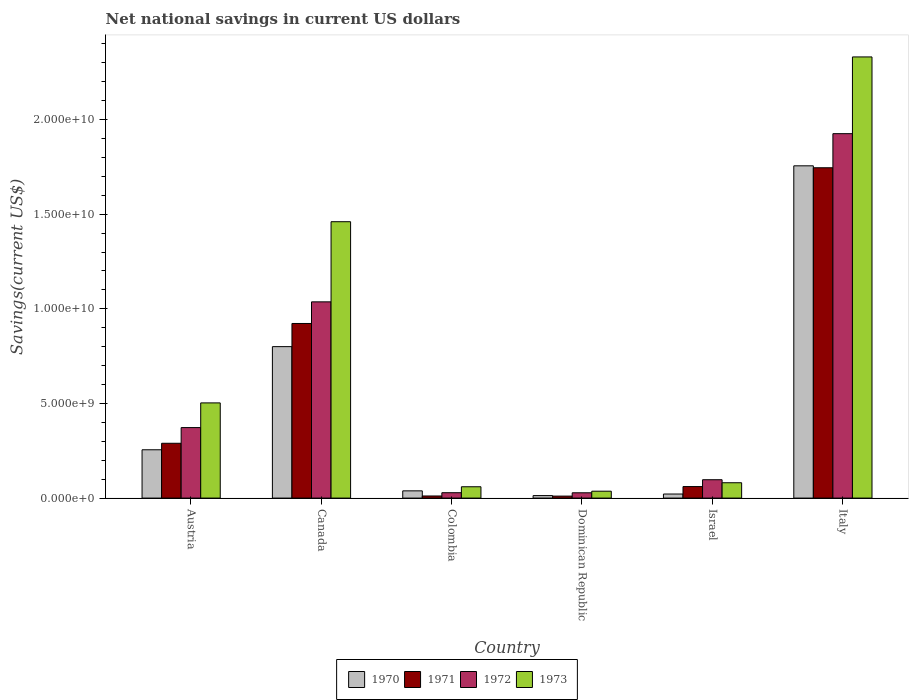How many different coloured bars are there?
Keep it short and to the point. 4. Are the number of bars per tick equal to the number of legend labels?
Provide a succinct answer. Yes. Are the number of bars on each tick of the X-axis equal?
Ensure brevity in your answer.  Yes. How many bars are there on the 1st tick from the left?
Make the answer very short. 4. What is the label of the 5th group of bars from the left?
Give a very brief answer. Israel. In how many cases, is the number of bars for a given country not equal to the number of legend labels?
Offer a terse response. 0. What is the net national savings in 1972 in Colombia?
Provide a succinct answer. 2.84e+08. Across all countries, what is the maximum net national savings in 1971?
Provide a succinct answer. 1.75e+1. Across all countries, what is the minimum net national savings in 1970?
Your response must be concise. 1.33e+08. In which country was the net national savings in 1970 minimum?
Ensure brevity in your answer.  Dominican Republic. What is the total net national savings in 1971 in the graph?
Your response must be concise. 3.04e+1. What is the difference between the net national savings in 1971 in Canada and that in Italy?
Ensure brevity in your answer.  -8.23e+09. What is the difference between the net national savings in 1971 in Austria and the net national savings in 1972 in Dominican Republic?
Provide a short and direct response. 2.62e+09. What is the average net national savings in 1973 per country?
Keep it short and to the point. 7.45e+09. What is the difference between the net national savings of/in 1970 and net national savings of/in 1971 in Dominican Republic?
Your answer should be very brief. 2.74e+07. What is the ratio of the net national savings in 1970 in Colombia to that in Italy?
Provide a succinct answer. 0.02. What is the difference between the highest and the second highest net national savings in 1972?
Give a very brief answer. 8.89e+09. What is the difference between the highest and the lowest net national savings in 1971?
Your answer should be compact. 1.73e+1. Is the sum of the net national savings in 1971 in Dominican Republic and Israel greater than the maximum net national savings in 1970 across all countries?
Your answer should be compact. No. Is it the case that in every country, the sum of the net national savings in 1971 and net national savings in 1970 is greater than the net national savings in 1973?
Provide a short and direct response. No. How many bars are there?
Your answer should be very brief. 24. Are all the bars in the graph horizontal?
Offer a terse response. No. What is the difference between two consecutive major ticks on the Y-axis?
Ensure brevity in your answer.  5.00e+09. Are the values on the major ticks of Y-axis written in scientific E-notation?
Ensure brevity in your answer.  Yes. Does the graph contain grids?
Your answer should be very brief. No. Where does the legend appear in the graph?
Offer a terse response. Bottom center. How many legend labels are there?
Keep it short and to the point. 4. What is the title of the graph?
Your response must be concise. Net national savings in current US dollars. What is the label or title of the X-axis?
Your answer should be very brief. Country. What is the label or title of the Y-axis?
Your answer should be very brief. Savings(current US$). What is the Savings(current US$) of 1970 in Austria?
Give a very brief answer. 2.55e+09. What is the Savings(current US$) in 1971 in Austria?
Your answer should be very brief. 2.90e+09. What is the Savings(current US$) of 1972 in Austria?
Make the answer very short. 3.73e+09. What is the Savings(current US$) in 1973 in Austria?
Make the answer very short. 5.03e+09. What is the Savings(current US$) in 1970 in Canada?
Offer a very short reply. 8.00e+09. What is the Savings(current US$) in 1971 in Canada?
Your response must be concise. 9.23e+09. What is the Savings(current US$) of 1972 in Canada?
Provide a succinct answer. 1.04e+1. What is the Savings(current US$) in 1973 in Canada?
Keep it short and to the point. 1.46e+1. What is the Savings(current US$) in 1970 in Colombia?
Offer a very short reply. 3.83e+08. What is the Savings(current US$) in 1971 in Colombia?
Keep it short and to the point. 1.11e+08. What is the Savings(current US$) in 1972 in Colombia?
Make the answer very short. 2.84e+08. What is the Savings(current US$) of 1973 in Colombia?
Ensure brevity in your answer.  5.98e+08. What is the Savings(current US$) of 1970 in Dominican Republic?
Make the answer very short. 1.33e+08. What is the Savings(current US$) of 1971 in Dominican Republic?
Provide a short and direct response. 1.05e+08. What is the Savings(current US$) in 1972 in Dominican Republic?
Your answer should be very brief. 2.80e+08. What is the Savings(current US$) in 1973 in Dominican Republic?
Provide a short and direct response. 3.65e+08. What is the Savings(current US$) of 1970 in Israel?
Your answer should be compact. 2.15e+08. What is the Savings(current US$) in 1971 in Israel?
Offer a very short reply. 6.09e+08. What is the Savings(current US$) in 1972 in Israel?
Offer a terse response. 9.71e+08. What is the Savings(current US$) in 1973 in Israel?
Your answer should be compact. 8.11e+08. What is the Savings(current US$) of 1970 in Italy?
Provide a succinct answer. 1.76e+1. What is the Savings(current US$) in 1971 in Italy?
Provide a succinct answer. 1.75e+1. What is the Savings(current US$) of 1972 in Italy?
Provide a succinct answer. 1.93e+1. What is the Savings(current US$) in 1973 in Italy?
Offer a very short reply. 2.33e+1. Across all countries, what is the maximum Savings(current US$) in 1970?
Keep it short and to the point. 1.76e+1. Across all countries, what is the maximum Savings(current US$) in 1971?
Make the answer very short. 1.75e+1. Across all countries, what is the maximum Savings(current US$) of 1972?
Offer a very short reply. 1.93e+1. Across all countries, what is the maximum Savings(current US$) in 1973?
Your response must be concise. 2.33e+1. Across all countries, what is the minimum Savings(current US$) in 1970?
Provide a succinct answer. 1.33e+08. Across all countries, what is the minimum Savings(current US$) of 1971?
Make the answer very short. 1.05e+08. Across all countries, what is the minimum Savings(current US$) of 1972?
Your response must be concise. 2.80e+08. Across all countries, what is the minimum Savings(current US$) in 1973?
Provide a short and direct response. 3.65e+08. What is the total Savings(current US$) of 1970 in the graph?
Provide a short and direct response. 2.88e+1. What is the total Savings(current US$) of 1971 in the graph?
Keep it short and to the point. 3.04e+1. What is the total Savings(current US$) in 1972 in the graph?
Give a very brief answer. 3.49e+1. What is the total Savings(current US$) in 1973 in the graph?
Give a very brief answer. 4.47e+1. What is the difference between the Savings(current US$) in 1970 in Austria and that in Canada?
Ensure brevity in your answer.  -5.45e+09. What is the difference between the Savings(current US$) of 1971 in Austria and that in Canada?
Provide a succinct answer. -6.33e+09. What is the difference between the Savings(current US$) in 1972 in Austria and that in Canada?
Your answer should be very brief. -6.64e+09. What is the difference between the Savings(current US$) of 1973 in Austria and that in Canada?
Make the answer very short. -9.57e+09. What is the difference between the Savings(current US$) in 1970 in Austria and that in Colombia?
Provide a succinct answer. 2.17e+09. What is the difference between the Savings(current US$) of 1971 in Austria and that in Colombia?
Your answer should be very brief. 2.78e+09. What is the difference between the Savings(current US$) in 1972 in Austria and that in Colombia?
Give a very brief answer. 3.44e+09. What is the difference between the Savings(current US$) in 1973 in Austria and that in Colombia?
Ensure brevity in your answer.  4.43e+09. What is the difference between the Savings(current US$) of 1970 in Austria and that in Dominican Republic?
Ensure brevity in your answer.  2.42e+09. What is the difference between the Savings(current US$) in 1971 in Austria and that in Dominican Republic?
Your answer should be very brief. 2.79e+09. What is the difference between the Savings(current US$) in 1972 in Austria and that in Dominican Republic?
Give a very brief answer. 3.44e+09. What is the difference between the Savings(current US$) in 1973 in Austria and that in Dominican Republic?
Your response must be concise. 4.66e+09. What is the difference between the Savings(current US$) of 1970 in Austria and that in Israel?
Your answer should be compact. 2.34e+09. What is the difference between the Savings(current US$) of 1971 in Austria and that in Israel?
Provide a short and direct response. 2.29e+09. What is the difference between the Savings(current US$) in 1972 in Austria and that in Israel?
Your answer should be compact. 2.75e+09. What is the difference between the Savings(current US$) of 1973 in Austria and that in Israel?
Make the answer very short. 4.22e+09. What is the difference between the Savings(current US$) in 1970 in Austria and that in Italy?
Offer a very short reply. -1.50e+1. What is the difference between the Savings(current US$) of 1971 in Austria and that in Italy?
Your answer should be compact. -1.46e+1. What is the difference between the Savings(current US$) in 1972 in Austria and that in Italy?
Provide a succinct answer. -1.55e+1. What is the difference between the Savings(current US$) in 1973 in Austria and that in Italy?
Keep it short and to the point. -1.83e+1. What is the difference between the Savings(current US$) in 1970 in Canada and that in Colombia?
Offer a terse response. 7.62e+09. What is the difference between the Savings(current US$) of 1971 in Canada and that in Colombia?
Provide a short and direct response. 9.11e+09. What is the difference between the Savings(current US$) in 1972 in Canada and that in Colombia?
Keep it short and to the point. 1.01e+1. What is the difference between the Savings(current US$) of 1973 in Canada and that in Colombia?
Provide a short and direct response. 1.40e+1. What is the difference between the Savings(current US$) of 1970 in Canada and that in Dominican Republic?
Your response must be concise. 7.87e+09. What is the difference between the Savings(current US$) in 1971 in Canada and that in Dominican Republic?
Give a very brief answer. 9.12e+09. What is the difference between the Savings(current US$) in 1972 in Canada and that in Dominican Republic?
Provide a short and direct response. 1.01e+1. What is the difference between the Savings(current US$) of 1973 in Canada and that in Dominican Republic?
Your answer should be very brief. 1.42e+1. What is the difference between the Savings(current US$) of 1970 in Canada and that in Israel?
Provide a short and direct response. 7.79e+09. What is the difference between the Savings(current US$) in 1971 in Canada and that in Israel?
Offer a very short reply. 8.62e+09. What is the difference between the Savings(current US$) in 1972 in Canada and that in Israel?
Give a very brief answer. 9.40e+09. What is the difference between the Savings(current US$) of 1973 in Canada and that in Israel?
Your response must be concise. 1.38e+1. What is the difference between the Savings(current US$) of 1970 in Canada and that in Italy?
Give a very brief answer. -9.55e+09. What is the difference between the Savings(current US$) of 1971 in Canada and that in Italy?
Give a very brief answer. -8.23e+09. What is the difference between the Savings(current US$) of 1972 in Canada and that in Italy?
Offer a very short reply. -8.89e+09. What is the difference between the Savings(current US$) of 1973 in Canada and that in Italy?
Provide a short and direct response. -8.71e+09. What is the difference between the Savings(current US$) of 1970 in Colombia and that in Dominican Republic?
Provide a short and direct response. 2.50e+08. What is the difference between the Savings(current US$) of 1971 in Colombia and that in Dominican Republic?
Offer a terse response. 6.03e+06. What is the difference between the Savings(current US$) of 1972 in Colombia and that in Dominican Republic?
Make the answer very short. 3.48e+06. What is the difference between the Savings(current US$) of 1973 in Colombia and that in Dominican Republic?
Offer a very short reply. 2.34e+08. What is the difference between the Savings(current US$) in 1970 in Colombia and that in Israel?
Keep it short and to the point. 1.68e+08. What is the difference between the Savings(current US$) in 1971 in Colombia and that in Israel?
Provide a short and direct response. -4.97e+08. What is the difference between the Savings(current US$) in 1972 in Colombia and that in Israel?
Offer a very short reply. -6.87e+08. What is the difference between the Savings(current US$) in 1973 in Colombia and that in Israel?
Your answer should be compact. -2.12e+08. What is the difference between the Savings(current US$) in 1970 in Colombia and that in Italy?
Give a very brief answer. -1.72e+1. What is the difference between the Savings(current US$) of 1971 in Colombia and that in Italy?
Provide a short and direct response. -1.73e+1. What is the difference between the Savings(current US$) of 1972 in Colombia and that in Italy?
Your answer should be very brief. -1.90e+1. What is the difference between the Savings(current US$) in 1973 in Colombia and that in Italy?
Your response must be concise. -2.27e+1. What is the difference between the Savings(current US$) in 1970 in Dominican Republic and that in Israel?
Provide a succinct answer. -8.19e+07. What is the difference between the Savings(current US$) in 1971 in Dominican Republic and that in Israel?
Keep it short and to the point. -5.03e+08. What is the difference between the Savings(current US$) in 1972 in Dominican Republic and that in Israel?
Offer a very short reply. -6.90e+08. What is the difference between the Savings(current US$) in 1973 in Dominican Republic and that in Israel?
Your answer should be very brief. -4.46e+08. What is the difference between the Savings(current US$) in 1970 in Dominican Republic and that in Italy?
Make the answer very short. -1.74e+1. What is the difference between the Savings(current US$) in 1971 in Dominican Republic and that in Italy?
Your answer should be very brief. -1.73e+1. What is the difference between the Savings(current US$) in 1972 in Dominican Republic and that in Italy?
Provide a succinct answer. -1.90e+1. What is the difference between the Savings(current US$) of 1973 in Dominican Republic and that in Italy?
Offer a very short reply. -2.29e+1. What is the difference between the Savings(current US$) of 1970 in Israel and that in Italy?
Your response must be concise. -1.73e+1. What is the difference between the Savings(current US$) in 1971 in Israel and that in Italy?
Ensure brevity in your answer.  -1.68e+1. What is the difference between the Savings(current US$) in 1972 in Israel and that in Italy?
Your answer should be compact. -1.83e+1. What is the difference between the Savings(current US$) in 1973 in Israel and that in Italy?
Provide a succinct answer. -2.25e+1. What is the difference between the Savings(current US$) in 1970 in Austria and the Savings(current US$) in 1971 in Canada?
Offer a terse response. -6.67e+09. What is the difference between the Savings(current US$) of 1970 in Austria and the Savings(current US$) of 1972 in Canada?
Your response must be concise. -7.82e+09. What is the difference between the Savings(current US$) in 1970 in Austria and the Savings(current US$) in 1973 in Canada?
Your answer should be very brief. -1.20e+1. What is the difference between the Savings(current US$) in 1971 in Austria and the Savings(current US$) in 1972 in Canada?
Keep it short and to the point. -7.47e+09. What is the difference between the Savings(current US$) in 1971 in Austria and the Savings(current US$) in 1973 in Canada?
Your answer should be compact. -1.17e+1. What is the difference between the Savings(current US$) in 1972 in Austria and the Savings(current US$) in 1973 in Canada?
Provide a succinct answer. -1.09e+1. What is the difference between the Savings(current US$) in 1970 in Austria and the Savings(current US$) in 1971 in Colombia?
Make the answer very short. 2.44e+09. What is the difference between the Savings(current US$) of 1970 in Austria and the Savings(current US$) of 1972 in Colombia?
Provide a succinct answer. 2.27e+09. What is the difference between the Savings(current US$) of 1970 in Austria and the Savings(current US$) of 1973 in Colombia?
Offer a terse response. 1.95e+09. What is the difference between the Savings(current US$) in 1971 in Austria and the Savings(current US$) in 1972 in Colombia?
Make the answer very short. 2.61e+09. What is the difference between the Savings(current US$) in 1971 in Austria and the Savings(current US$) in 1973 in Colombia?
Ensure brevity in your answer.  2.30e+09. What is the difference between the Savings(current US$) of 1972 in Austria and the Savings(current US$) of 1973 in Colombia?
Provide a succinct answer. 3.13e+09. What is the difference between the Savings(current US$) of 1970 in Austria and the Savings(current US$) of 1971 in Dominican Republic?
Keep it short and to the point. 2.45e+09. What is the difference between the Savings(current US$) in 1970 in Austria and the Savings(current US$) in 1972 in Dominican Republic?
Offer a terse response. 2.27e+09. What is the difference between the Savings(current US$) in 1970 in Austria and the Savings(current US$) in 1973 in Dominican Republic?
Keep it short and to the point. 2.19e+09. What is the difference between the Savings(current US$) of 1971 in Austria and the Savings(current US$) of 1972 in Dominican Republic?
Keep it short and to the point. 2.62e+09. What is the difference between the Savings(current US$) of 1971 in Austria and the Savings(current US$) of 1973 in Dominican Republic?
Offer a very short reply. 2.53e+09. What is the difference between the Savings(current US$) in 1972 in Austria and the Savings(current US$) in 1973 in Dominican Republic?
Your answer should be very brief. 3.36e+09. What is the difference between the Savings(current US$) of 1970 in Austria and the Savings(current US$) of 1971 in Israel?
Give a very brief answer. 1.94e+09. What is the difference between the Savings(current US$) of 1970 in Austria and the Savings(current US$) of 1972 in Israel?
Provide a short and direct response. 1.58e+09. What is the difference between the Savings(current US$) in 1970 in Austria and the Savings(current US$) in 1973 in Israel?
Your answer should be compact. 1.74e+09. What is the difference between the Savings(current US$) of 1971 in Austria and the Savings(current US$) of 1972 in Israel?
Offer a very short reply. 1.93e+09. What is the difference between the Savings(current US$) in 1971 in Austria and the Savings(current US$) in 1973 in Israel?
Give a very brief answer. 2.09e+09. What is the difference between the Savings(current US$) in 1972 in Austria and the Savings(current US$) in 1973 in Israel?
Offer a very short reply. 2.91e+09. What is the difference between the Savings(current US$) in 1970 in Austria and the Savings(current US$) in 1971 in Italy?
Offer a terse response. -1.49e+1. What is the difference between the Savings(current US$) of 1970 in Austria and the Savings(current US$) of 1972 in Italy?
Make the answer very short. -1.67e+1. What is the difference between the Savings(current US$) of 1970 in Austria and the Savings(current US$) of 1973 in Italy?
Provide a short and direct response. -2.08e+1. What is the difference between the Savings(current US$) in 1971 in Austria and the Savings(current US$) in 1972 in Italy?
Your answer should be very brief. -1.64e+1. What is the difference between the Savings(current US$) of 1971 in Austria and the Savings(current US$) of 1973 in Italy?
Provide a succinct answer. -2.04e+1. What is the difference between the Savings(current US$) in 1972 in Austria and the Savings(current US$) in 1973 in Italy?
Provide a short and direct response. -1.96e+1. What is the difference between the Savings(current US$) in 1970 in Canada and the Savings(current US$) in 1971 in Colombia?
Keep it short and to the point. 7.89e+09. What is the difference between the Savings(current US$) of 1970 in Canada and the Savings(current US$) of 1972 in Colombia?
Your response must be concise. 7.72e+09. What is the difference between the Savings(current US$) of 1970 in Canada and the Savings(current US$) of 1973 in Colombia?
Your answer should be compact. 7.40e+09. What is the difference between the Savings(current US$) of 1971 in Canada and the Savings(current US$) of 1972 in Colombia?
Your response must be concise. 8.94e+09. What is the difference between the Savings(current US$) in 1971 in Canada and the Savings(current US$) in 1973 in Colombia?
Provide a succinct answer. 8.63e+09. What is the difference between the Savings(current US$) of 1972 in Canada and the Savings(current US$) of 1973 in Colombia?
Provide a short and direct response. 9.77e+09. What is the difference between the Savings(current US$) of 1970 in Canada and the Savings(current US$) of 1971 in Dominican Republic?
Give a very brief answer. 7.90e+09. What is the difference between the Savings(current US$) of 1970 in Canada and the Savings(current US$) of 1972 in Dominican Republic?
Your answer should be compact. 7.72e+09. What is the difference between the Savings(current US$) of 1970 in Canada and the Savings(current US$) of 1973 in Dominican Republic?
Your response must be concise. 7.64e+09. What is the difference between the Savings(current US$) in 1971 in Canada and the Savings(current US$) in 1972 in Dominican Republic?
Ensure brevity in your answer.  8.94e+09. What is the difference between the Savings(current US$) in 1971 in Canada and the Savings(current US$) in 1973 in Dominican Republic?
Your answer should be very brief. 8.86e+09. What is the difference between the Savings(current US$) in 1972 in Canada and the Savings(current US$) in 1973 in Dominican Republic?
Provide a succinct answer. 1.00e+1. What is the difference between the Savings(current US$) in 1970 in Canada and the Savings(current US$) in 1971 in Israel?
Give a very brief answer. 7.39e+09. What is the difference between the Savings(current US$) of 1970 in Canada and the Savings(current US$) of 1972 in Israel?
Provide a short and direct response. 7.03e+09. What is the difference between the Savings(current US$) in 1970 in Canada and the Savings(current US$) in 1973 in Israel?
Provide a short and direct response. 7.19e+09. What is the difference between the Savings(current US$) in 1971 in Canada and the Savings(current US$) in 1972 in Israel?
Offer a terse response. 8.25e+09. What is the difference between the Savings(current US$) in 1971 in Canada and the Savings(current US$) in 1973 in Israel?
Offer a very short reply. 8.41e+09. What is the difference between the Savings(current US$) of 1972 in Canada and the Savings(current US$) of 1973 in Israel?
Ensure brevity in your answer.  9.56e+09. What is the difference between the Savings(current US$) in 1970 in Canada and the Savings(current US$) in 1971 in Italy?
Offer a terse response. -9.45e+09. What is the difference between the Savings(current US$) in 1970 in Canada and the Savings(current US$) in 1972 in Italy?
Your answer should be very brief. -1.13e+1. What is the difference between the Savings(current US$) in 1970 in Canada and the Savings(current US$) in 1973 in Italy?
Offer a terse response. -1.53e+1. What is the difference between the Savings(current US$) of 1971 in Canada and the Savings(current US$) of 1972 in Italy?
Your response must be concise. -1.00e+1. What is the difference between the Savings(current US$) in 1971 in Canada and the Savings(current US$) in 1973 in Italy?
Keep it short and to the point. -1.41e+1. What is the difference between the Savings(current US$) of 1972 in Canada and the Savings(current US$) of 1973 in Italy?
Your response must be concise. -1.29e+1. What is the difference between the Savings(current US$) in 1970 in Colombia and the Savings(current US$) in 1971 in Dominican Republic?
Make the answer very short. 2.77e+08. What is the difference between the Savings(current US$) of 1970 in Colombia and the Savings(current US$) of 1972 in Dominican Republic?
Keep it short and to the point. 1.02e+08. What is the difference between the Savings(current US$) of 1970 in Colombia and the Savings(current US$) of 1973 in Dominican Republic?
Provide a short and direct response. 1.82e+07. What is the difference between the Savings(current US$) in 1971 in Colombia and the Savings(current US$) in 1972 in Dominican Republic?
Provide a succinct answer. -1.69e+08. What is the difference between the Savings(current US$) of 1971 in Colombia and the Savings(current US$) of 1973 in Dominican Republic?
Ensure brevity in your answer.  -2.53e+08. What is the difference between the Savings(current US$) of 1972 in Colombia and the Savings(current US$) of 1973 in Dominican Republic?
Make the answer very short. -8.05e+07. What is the difference between the Savings(current US$) in 1970 in Colombia and the Savings(current US$) in 1971 in Israel?
Make the answer very short. -2.26e+08. What is the difference between the Savings(current US$) in 1970 in Colombia and the Savings(current US$) in 1972 in Israel?
Give a very brief answer. -5.88e+08. What is the difference between the Savings(current US$) of 1970 in Colombia and the Savings(current US$) of 1973 in Israel?
Your answer should be compact. -4.28e+08. What is the difference between the Savings(current US$) in 1971 in Colombia and the Savings(current US$) in 1972 in Israel?
Keep it short and to the point. -8.59e+08. What is the difference between the Savings(current US$) in 1971 in Colombia and the Savings(current US$) in 1973 in Israel?
Keep it short and to the point. -6.99e+08. What is the difference between the Savings(current US$) in 1972 in Colombia and the Savings(current US$) in 1973 in Israel?
Keep it short and to the point. -5.27e+08. What is the difference between the Savings(current US$) of 1970 in Colombia and the Savings(current US$) of 1971 in Italy?
Your response must be concise. -1.71e+1. What is the difference between the Savings(current US$) of 1970 in Colombia and the Savings(current US$) of 1972 in Italy?
Ensure brevity in your answer.  -1.89e+1. What is the difference between the Savings(current US$) in 1970 in Colombia and the Savings(current US$) in 1973 in Italy?
Give a very brief answer. -2.29e+1. What is the difference between the Savings(current US$) of 1971 in Colombia and the Savings(current US$) of 1972 in Italy?
Your answer should be compact. -1.91e+1. What is the difference between the Savings(current US$) in 1971 in Colombia and the Savings(current US$) in 1973 in Italy?
Offer a very short reply. -2.32e+1. What is the difference between the Savings(current US$) of 1972 in Colombia and the Savings(current US$) of 1973 in Italy?
Offer a very short reply. -2.30e+1. What is the difference between the Savings(current US$) in 1970 in Dominican Republic and the Savings(current US$) in 1971 in Israel?
Ensure brevity in your answer.  -4.76e+08. What is the difference between the Savings(current US$) in 1970 in Dominican Republic and the Savings(current US$) in 1972 in Israel?
Provide a succinct answer. -8.38e+08. What is the difference between the Savings(current US$) in 1970 in Dominican Republic and the Savings(current US$) in 1973 in Israel?
Ensure brevity in your answer.  -6.78e+08. What is the difference between the Savings(current US$) in 1971 in Dominican Republic and the Savings(current US$) in 1972 in Israel?
Give a very brief answer. -8.65e+08. What is the difference between the Savings(current US$) of 1971 in Dominican Republic and the Savings(current US$) of 1973 in Israel?
Your response must be concise. -7.05e+08. What is the difference between the Savings(current US$) in 1972 in Dominican Republic and the Savings(current US$) in 1973 in Israel?
Offer a terse response. -5.30e+08. What is the difference between the Savings(current US$) of 1970 in Dominican Republic and the Savings(current US$) of 1971 in Italy?
Provide a succinct answer. -1.73e+1. What is the difference between the Savings(current US$) in 1970 in Dominican Republic and the Savings(current US$) in 1972 in Italy?
Make the answer very short. -1.91e+1. What is the difference between the Savings(current US$) of 1970 in Dominican Republic and the Savings(current US$) of 1973 in Italy?
Give a very brief answer. -2.32e+1. What is the difference between the Savings(current US$) in 1971 in Dominican Republic and the Savings(current US$) in 1972 in Italy?
Ensure brevity in your answer.  -1.91e+1. What is the difference between the Savings(current US$) of 1971 in Dominican Republic and the Savings(current US$) of 1973 in Italy?
Offer a terse response. -2.32e+1. What is the difference between the Savings(current US$) of 1972 in Dominican Republic and the Savings(current US$) of 1973 in Italy?
Offer a very short reply. -2.30e+1. What is the difference between the Savings(current US$) in 1970 in Israel and the Savings(current US$) in 1971 in Italy?
Ensure brevity in your answer.  -1.72e+1. What is the difference between the Savings(current US$) of 1970 in Israel and the Savings(current US$) of 1972 in Italy?
Keep it short and to the point. -1.90e+1. What is the difference between the Savings(current US$) of 1970 in Israel and the Savings(current US$) of 1973 in Italy?
Provide a succinct answer. -2.31e+1. What is the difference between the Savings(current US$) in 1971 in Israel and the Savings(current US$) in 1972 in Italy?
Your answer should be compact. -1.86e+1. What is the difference between the Savings(current US$) of 1971 in Israel and the Savings(current US$) of 1973 in Italy?
Provide a succinct answer. -2.27e+1. What is the difference between the Savings(current US$) in 1972 in Israel and the Savings(current US$) in 1973 in Italy?
Make the answer very short. -2.23e+1. What is the average Savings(current US$) of 1970 per country?
Provide a short and direct response. 4.81e+09. What is the average Savings(current US$) in 1971 per country?
Make the answer very short. 5.07e+09. What is the average Savings(current US$) in 1972 per country?
Your answer should be very brief. 5.81e+09. What is the average Savings(current US$) in 1973 per country?
Provide a short and direct response. 7.45e+09. What is the difference between the Savings(current US$) in 1970 and Savings(current US$) in 1971 in Austria?
Ensure brevity in your answer.  -3.44e+08. What is the difference between the Savings(current US$) in 1970 and Savings(current US$) in 1972 in Austria?
Your response must be concise. -1.17e+09. What is the difference between the Savings(current US$) in 1970 and Savings(current US$) in 1973 in Austria?
Offer a terse response. -2.48e+09. What is the difference between the Savings(current US$) of 1971 and Savings(current US$) of 1972 in Austria?
Ensure brevity in your answer.  -8.29e+08. What is the difference between the Savings(current US$) of 1971 and Savings(current US$) of 1973 in Austria?
Provide a succinct answer. -2.13e+09. What is the difference between the Savings(current US$) in 1972 and Savings(current US$) in 1973 in Austria?
Provide a succinct answer. -1.30e+09. What is the difference between the Savings(current US$) of 1970 and Savings(current US$) of 1971 in Canada?
Your answer should be very brief. -1.22e+09. What is the difference between the Savings(current US$) in 1970 and Savings(current US$) in 1972 in Canada?
Your response must be concise. -2.37e+09. What is the difference between the Savings(current US$) of 1970 and Savings(current US$) of 1973 in Canada?
Provide a short and direct response. -6.60e+09. What is the difference between the Savings(current US$) in 1971 and Savings(current US$) in 1972 in Canada?
Your answer should be compact. -1.14e+09. What is the difference between the Savings(current US$) in 1971 and Savings(current US$) in 1973 in Canada?
Provide a short and direct response. -5.38e+09. What is the difference between the Savings(current US$) in 1972 and Savings(current US$) in 1973 in Canada?
Ensure brevity in your answer.  -4.23e+09. What is the difference between the Savings(current US$) of 1970 and Savings(current US$) of 1971 in Colombia?
Make the answer very short. 2.71e+08. What is the difference between the Savings(current US$) of 1970 and Savings(current US$) of 1972 in Colombia?
Provide a succinct answer. 9.87e+07. What is the difference between the Savings(current US$) of 1970 and Savings(current US$) of 1973 in Colombia?
Give a very brief answer. -2.16e+08. What is the difference between the Savings(current US$) of 1971 and Savings(current US$) of 1972 in Colombia?
Ensure brevity in your answer.  -1.73e+08. What is the difference between the Savings(current US$) in 1971 and Savings(current US$) in 1973 in Colombia?
Keep it short and to the point. -4.87e+08. What is the difference between the Savings(current US$) in 1972 and Savings(current US$) in 1973 in Colombia?
Offer a very short reply. -3.14e+08. What is the difference between the Savings(current US$) in 1970 and Savings(current US$) in 1971 in Dominican Republic?
Offer a terse response. 2.74e+07. What is the difference between the Savings(current US$) of 1970 and Savings(current US$) of 1972 in Dominican Republic?
Offer a very short reply. -1.48e+08. What is the difference between the Savings(current US$) in 1970 and Savings(current US$) in 1973 in Dominican Republic?
Offer a terse response. -2.32e+08. What is the difference between the Savings(current US$) in 1971 and Savings(current US$) in 1972 in Dominican Republic?
Make the answer very short. -1.75e+08. What is the difference between the Savings(current US$) in 1971 and Savings(current US$) in 1973 in Dominican Republic?
Your answer should be compact. -2.59e+08. What is the difference between the Savings(current US$) of 1972 and Savings(current US$) of 1973 in Dominican Republic?
Provide a short and direct response. -8.40e+07. What is the difference between the Savings(current US$) in 1970 and Savings(current US$) in 1971 in Israel?
Ensure brevity in your answer.  -3.94e+08. What is the difference between the Savings(current US$) of 1970 and Savings(current US$) of 1972 in Israel?
Provide a short and direct response. -7.56e+08. What is the difference between the Savings(current US$) of 1970 and Savings(current US$) of 1973 in Israel?
Give a very brief answer. -5.96e+08. What is the difference between the Savings(current US$) of 1971 and Savings(current US$) of 1972 in Israel?
Your answer should be compact. -3.62e+08. What is the difference between the Savings(current US$) in 1971 and Savings(current US$) in 1973 in Israel?
Your response must be concise. -2.02e+08. What is the difference between the Savings(current US$) of 1972 and Savings(current US$) of 1973 in Israel?
Give a very brief answer. 1.60e+08. What is the difference between the Savings(current US$) of 1970 and Savings(current US$) of 1971 in Italy?
Make the answer very short. 1.03e+08. What is the difference between the Savings(current US$) of 1970 and Savings(current US$) of 1972 in Italy?
Provide a short and direct response. -1.70e+09. What is the difference between the Savings(current US$) of 1970 and Savings(current US$) of 1973 in Italy?
Keep it short and to the point. -5.75e+09. What is the difference between the Savings(current US$) of 1971 and Savings(current US$) of 1972 in Italy?
Your response must be concise. -1.80e+09. What is the difference between the Savings(current US$) of 1971 and Savings(current US$) of 1973 in Italy?
Offer a terse response. -5.86e+09. What is the difference between the Savings(current US$) of 1972 and Savings(current US$) of 1973 in Italy?
Your response must be concise. -4.05e+09. What is the ratio of the Savings(current US$) of 1970 in Austria to that in Canada?
Provide a succinct answer. 0.32. What is the ratio of the Savings(current US$) in 1971 in Austria to that in Canada?
Offer a very short reply. 0.31. What is the ratio of the Savings(current US$) in 1972 in Austria to that in Canada?
Your answer should be compact. 0.36. What is the ratio of the Savings(current US$) of 1973 in Austria to that in Canada?
Your answer should be compact. 0.34. What is the ratio of the Savings(current US$) in 1970 in Austria to that in Colombia?
Your answer should be compact. 6.67. What is the ratio of the Savings(current US$) in 1971 in Austria to that in Colombia?
Provide a short and direct response. 25.99. What is the ratio of the Savings(current US$) in 1972 in Austria to that in Colombia?
Your response must be concise. 13.12. What is the ratio of the Savings(current US$) in 1973 in Austria to that in Colombia?
Keep it short and to the point. 8.4. What is the ratio of the Savings(current US$) in 1970 in Austria to that in Dominican Republic?
Keep it short and to the point. 19.23. What is the ratio of the Savings(current US$) of 1971 in Austria to that in Dominican Republic?
Give a very brief answer. 27.48. What is the ratio of the Savings(current US$) of 1972 in Austria to that in Dominican Republic?
Your answer should be compact. 13.28. What is the ratio of the Savings(current US$) of 1973 in Austria to that in Dominican Republic?
Ensure brevity in your answer.  13.8. What is the ratio of the Savings(current US$) of 1970 in Austria to that in Israel?
Your answer should be very brief. 11.89. What is the ratio of the Savings(current US$) of 1971 in Austria to that in Israel?
Keep it short and to the point. 4.76. What is the ratio of the Savings(current US$) in 1972 in Austria to that in Israel?
Your response must be concise. 3.84. What is the ratio of the Savings(current US$) of 1973 in Austria to that in Israel?
Provide a short and direct response. 6.2. What is the ratio of the Savings(current US$) of 1970 in Austria to that in Italy?
Offer a very short reply. 0.15. What is the ratio of the Savings(current US$) of 1971 in Austria to that in Italy?
Offer a very short reply. 0.17. What is the ratio of the Savings(current US$) in 1972 in Austria to that in Italy?
Your answer should be very brief. 0.19. What is the ratio of the Savings(current US$) in 1973 in Austria to that in Italy?
Ensure brevity in your answer.  0.22. What is the ratio of the Savings(current US$) in 1970 in Canada to that in Colombia?
Your answer should be compact. 20.91. What is the ratio of the Savings(current US$) in 1971 in Canada to that in Colombia?
Give a very brief answer. 82.79. What is the ratio of the Savings(current US$) of 1972 in Canada to that in Colombia?
Ensure brevity in your answer.  36.51. What is the ratio of the Savings(current US$) in 1973 in Canada to that in Colombia?
Your answer should be very brief. 24.4. What is the ratio of the Savings(current US$) in 1970 in Canada to that in Dominican Republic?
Give a very brief answer. 60.27. What is the ratio of the Savings(current US$) in 1971 in Canada to that in Dominican Republic?
Offer a very short reply. 87.52. What is the ratio of the Savings(current US$) in 1972 in Canada to that in Dominican Republic?
Provide a short and direct response. 36.96. What is the ratio of the Savings(current US$) in 1973 in Canada to that in Dominican Republic?
Make the answer very short. 40.06. What is the ratio of the Savings(current US$) in 1970 in Canada to that in Israel?
Your answer should be very brief. 37.28. What is the ratio of the Savings(current US$) of 1971 in Canada to that in Israel?
Provide a short and direct response. 15.16. What is the ratio of the Savings(current US$) in 1972 in Canada to that in Israel?
Offer a very short reply. 10.68. What is the ratio of the Savings(current US$) of 1973 in Canada to that in Israel?
Keep it short and to the point. 18.01. What is the ratio of the Savings(current US$) of 1970 in Canada to that in Italy?
Provide a short and direct response. 0.46. What is the ratio of the Savings(current US$) of 1971 in Canada to that in Italy?
Keep it short and to the point. 0.53. What is the ratio of the Savings(current US$) of 1972 in Canada to that in Italy?
Provide a short and direct response. 0.54. What is the ratio of the Savings(current US$) of 1973 in Canada to that in Italy?
Give a very brief answer. 0.63. What is the ratio of the Savings(current US$) of 1970 in Colombia to that in Dominican Republic?
Offer a terse response. 2.88. What is the ratio of the Savings(current US$) of 1971 in Colombia to that in Dominican Republic?
Provide a short and direct response. 1.06. What is the ratio of the Savings(current US$) in 1972 in Colombia to that in Dominican Republic?
Keep it short and to the point. 1.01. What is the ratio of the Savings(current US$) of 1973 in Colombia to that in Dominican Republic?
Offer a very short reply. 1.64. What is the ratio of the Savings(current US$) of 1970 in Colombia to that in Israel?
Make the answer very short. 1.78. What is the ratio of the Savings(current US$) of 1971 in Colombia to that in Israel?
Your answer should be very brief. 0.18. What is the ratio of the Savings(current US$) of 1972 in Colombia to that in Israel?
Offer a terse response. 0.29. What is the ratio of the Savings(current US$) of 1973 in Colombia to that in Israel?
Offer a very short reply. 0.74. What is the ratio of the Savings(current US$) in 1970 in Colombia to that in Italy?
Provide a short and direct response. 0.02. What is the ratio of the Savings(current US$) in 1971 in Colombia to that in Italy?
Your response must be concise. 0.01. What is the ratio of the Savings(current US$) in 1972 in Colombia to that in Italy?
Provide a succinct answer. 0.01. What is the ratio of the Savings(current US$) in 1973 in Colombia to that in Italy?
Your answer should be very brief. 0.03. What is the ratio of the Savings(current US$) in 1970 in Dominican Republic to that in Israel?
Keep it short and to the point. 0.62. What is the ratio of the Savings(current US$) of 1971 in Dominican Republic to that in Israel?
Your answer should be compact. 0.17. What is the ratio of the Savings(current US$) in 1972 in Dominican Republic to that in Israel?
Keep it short and to the point. 0.29. What is the ratio of the Savings(current US$) in 1973 in Dominican Republic to that in Israel?
Ensure brevity in your answer.  0.45. What is the ratio of the Savings(current US$) of 1970 in Dominican Republic to that in Italy?
Your answer should be very brief. 0.01. What is the ratio of the Savings(current US$) of 1971 in Dominican Republic to that in Italy?
Make the answer very short. 0.01. What is the ratio of the Savings(current US$) of 1972 in Dominican Republic to that in Italy?
Your response must be concise. 0.01. What is the ratio of the Savings(current US$) of 1973 in Dominican Republic to that in Italy?
Your answer should be very brief. 0.02. What is the ratio of the Savings(current US$) of 1970 in Israel to that in Italy?
Provide a short and direct response. 0.01. What is the ratio of the Savings(current US$) of 1971 in Israel to that in Italy?
Your response must be concise. 0.03. What is the ratio of the Savings(current US$) in 1972 in Israel to that in Italy?
Keep it short and to the point. 0.05. What is the ratio of the Savings(current US$) of 1973 in Israel to that in Italy?
Provide a short and direct response. 0.03. What is the difference between the highest and the second highest Savings(current US$) of 1970?
Your answer should be very brief. 9.55e+09. What is the difference between the highest and the second highest Savings(current US$) in 1971?
Give a very brief answer. 8.23e+09. What is the difference between the highest and the second highest Savings(current US$) in 1972?
Provide a short and direct response. 8.89e+09. What is the difference between the highest and the second highest Savings(current US$) of 1973?
Offer a very short reply. 8.71e+09. What is the difference between the highest and the lowest Savings(current US$) in 1970?
Give a very brief answer. 1.74e+1. What is the difference between the highest and the lowest Savings(current US$) in 1971?
Your answer should be compact. 1.73e+1. What is the difference between the highest and the lowest Savings(current US$) in 1972?
Offer a very short reply. 1.90e+1. What is the difference between the highest and the lowest Savings(current US$) in 1973?
Provide a short and direct response. 2.29e+1. 